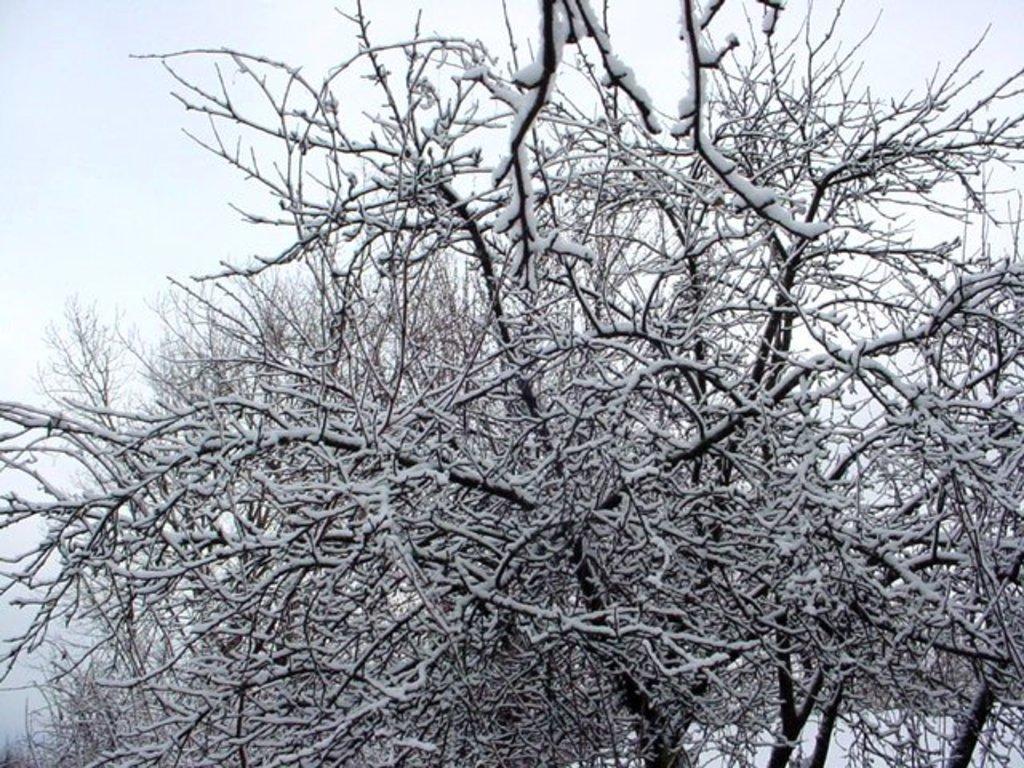How would you summarize this image in a sentence or two? In this picture I can see trees and I can see snow on the ground and on the trees and I can see a cloudy sky. 